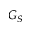Convert formula to latex. <formula><loc_0><loc_0><loc_500><loc_500>G _ { S }</formula> 